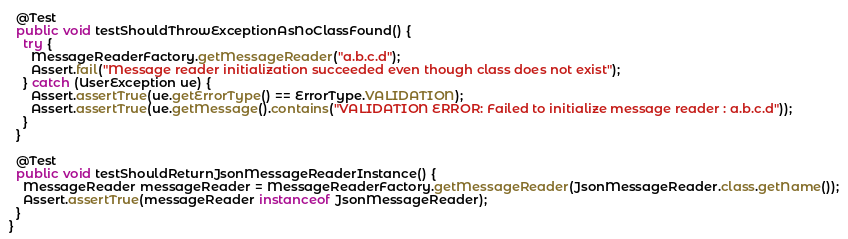Convert code to text. <code><loc_0><loc_0><loc_500><loc_500><_Java_>  @Test
  public void testShouldThrowExceptionAsNoClassFound() {
    try {
      MessageReaderFactory.getMessageReader("a.b.c.d");
      Assert.fail("Message reader initialization succeeded even though class does not exist");
    } catch (UserException ue) {
      Assert.assertTrue(ue.getErrorType() == ErrorType.VALIDATION);
      Assert.assertTrue(ue.getMessage().contains("VALIDATION ERROR: Failed to initialize message reader : a.b.c.d"));
    }
  }

  @Test
  public void testShouldReturnJsonMessageReaderInstance() {
    MessageReader messageReader = MessageReaderFactory.getMessageReader(JsonMessageReader.class.getName());
    Assert.assertTrue(messageReader instanceof JsonMessageReader);
  }
}
</code> 